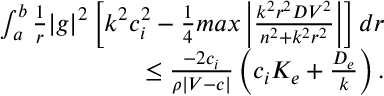Convert formula to latex. <formula><loc_0><loc_0><loc_500><loc_500>\begin{array} { r } { \int _ { a } ^ { b } \frac { 1 } { r } | g | ^ { 2 } \left [ k ^ { 2 } c _ { i } ^ { 2 } - \frac { 1 } { 4 } \max \left | \frac { k ^ { 2 } r ^ { 2 } D V ^ { 2 } } { n ^ { 2 } + k ^ { 2 } r ^ { 2 } } \right | \right ] d r } \\ { \leq \frac { - 2 c _ { i } } { \rho | V - c | } \left ( c _ { i } K _ { e } + \frac { D _ { e } } { k } \right ) . } \end{array}</formula> 